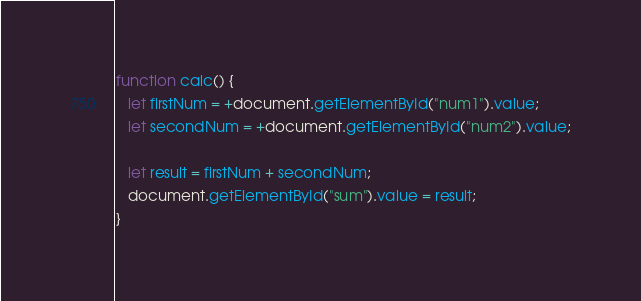<code> <loc_0><loc_0><loc_500><loc_500><_JavaScript_>function calc() {
   let firstNum = +document.getElementById("num1").value;
   let secondNum = +document.getElementById("num2").value;

   let result = firstNum + secondNum;
   document.getElementById("sum").value = result;
}</code> 